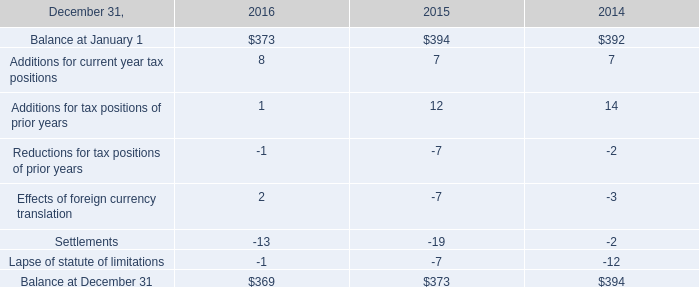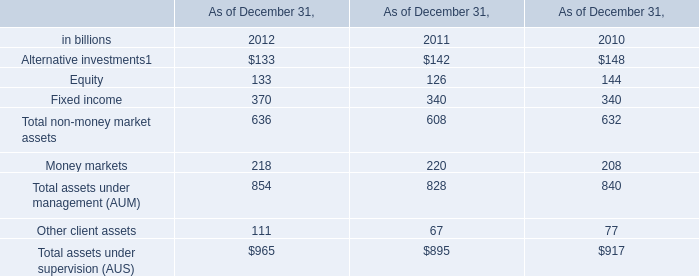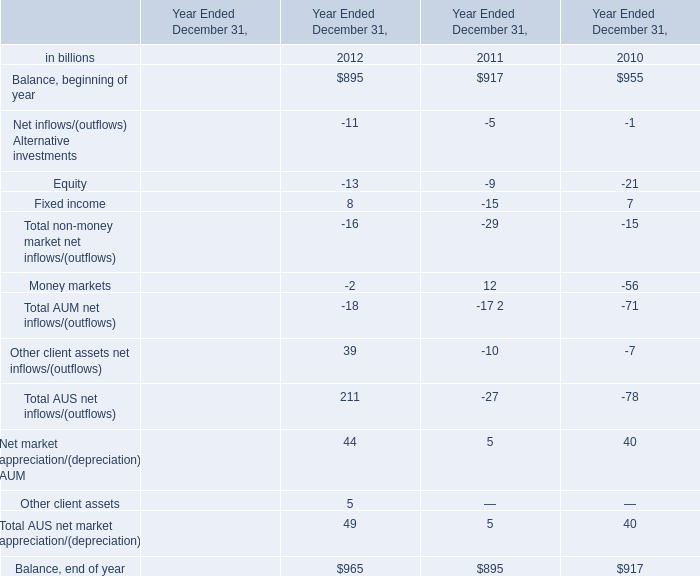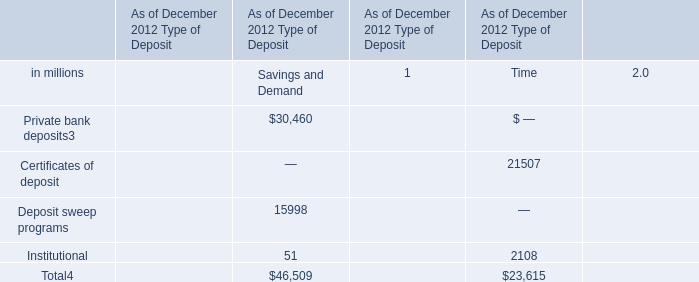what was the percentage change in the unrecognized tax benefits from 2014 to 2015? 
Computations: ((373 - 394) / 394)
Answer: -0.0533. 